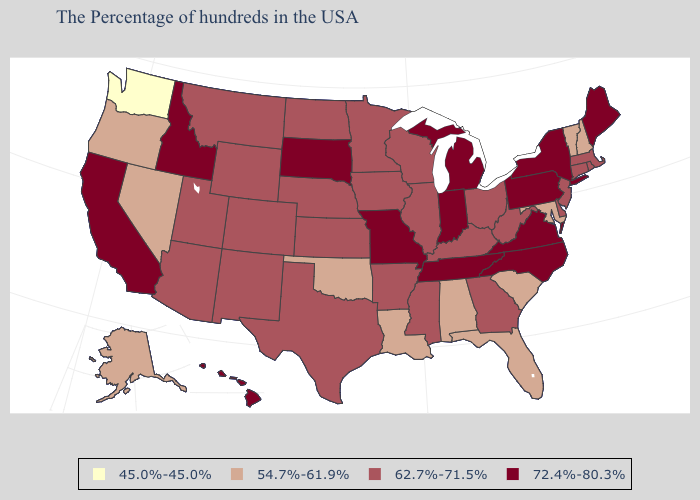Among the states that border Washington , does Oregon have the lowest value?
Give a very brief answer. Yes. Name the states that have a value in the range 72.4%-80.3%?
Answer briefly. Maine, New York, Pennsylvania, Virginia, North Carolina, Michigan, Indiana, Tennessee, Missouri, South Dakota, Idaho, California, Hawaii. Which states have the highest value in the USA?
Be succinct. Maine, New York, Pennsylvania, Virginia, North Carolina, Michigan, Indiana, Tennessee, Missouri, South Dakota, Idaho, California, Hawaii. Name the states that have a value in the range 72.4%-80.3%?
Short answer required. Maine, New York, Pennsylvania, Virginia, North Carolina, Michigan, Indiana, Tennessee, Missouri, South Dakota, Idaho, California, Hawaii. Does California have the same value as Colorado?
Short answer required. No. Does Mississippi have a lower value than New York?
Be succinct. Yes. What is the value of South Carolina?
Be succinct. 54.7%-61.9%. Name the states that have a value in the range 45.0%-45.0%?
Concise answer only. Washington. Name the states that have a value in the range 45.0%-45.0%?
Short answer required. Washington. What is the highest value in the USA?
Give a very brief answer. 72.4%-80.3%. What is the value of Pennsylvania?
Answer briefly. 72.4%-80.3%. What is the value of Texas?
Quick response, please. 62.7%-71.5%. Is the legend a continuous bar?
Quick response, please. No. Does Washington have the lowest value in the USA?
Short answer required. Yes. Does North Carolina have the lowest value in the USA?
Keep it brief. No. 